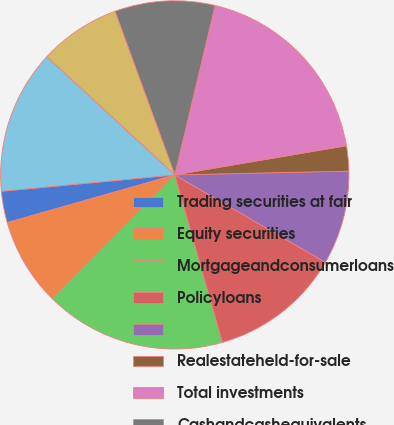Convert chart. <chart><loc_0><loc_0><loc_500><loc_500><pie_chart><fcel>Trading securities at fair<fcel>Equity securities<fcel>Mortgageandconsumerloans<fcel>Policyloans<fcel>Unnamed: 4<fcel>Realestateheld-for-sale<fcel>Total investments<fcel>Cashandcashequivalents<fcel>Accruedinvestmentincome<fcel>Premiumsandotherreceivables<nl><fcel>2.91%<fcel>8.14%<fcel>16.86%<fcel>12.21%<fcel>8.72%<fcel>2.33%<fcel>18.6%<fcel>9.3%<fcel>7.56%<fcel>13.37%<nl></chart> 